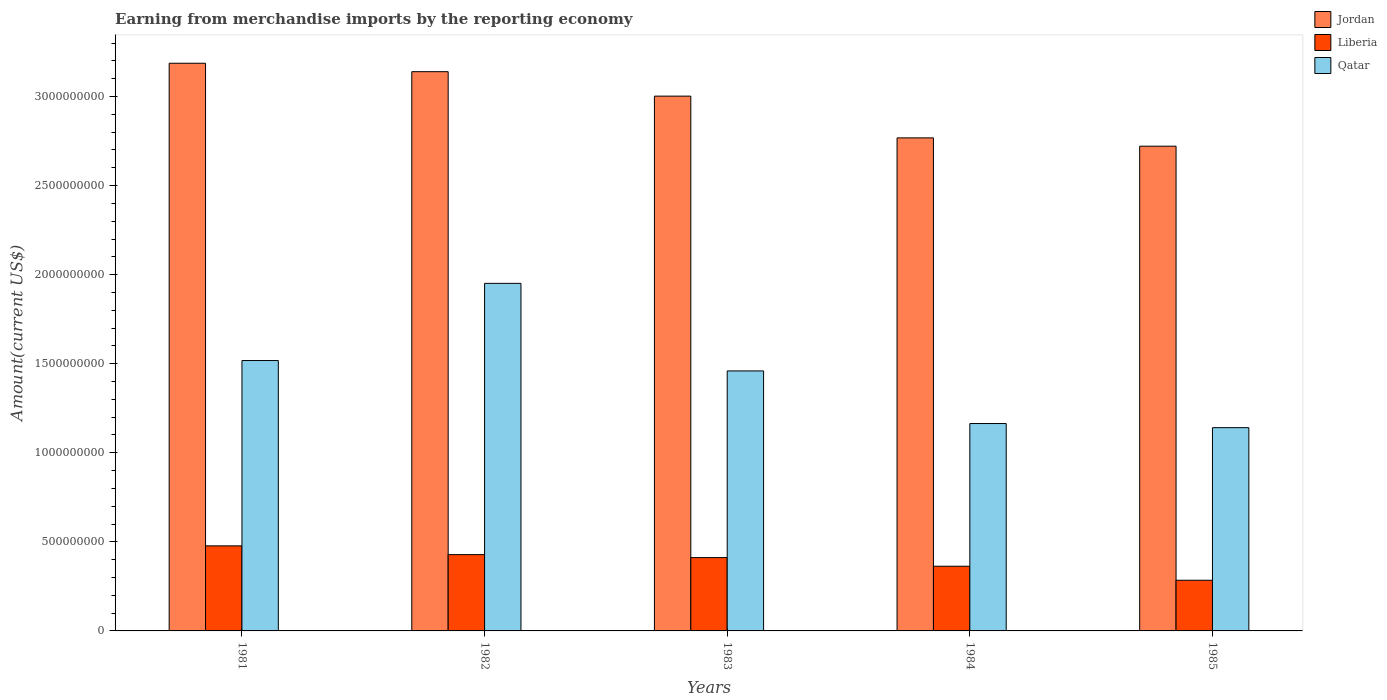How many groups of bars are there?
Provide a short and direct response. 5. How many bars are there on the 1st tick from the right?
Provide a short and direct response. 3. What is the label of the 5th group of bars from the left?
Provide a short and direct response. 1985. In how many cases, is the number of bars for a given year not equal to the number of legend labels?
Your response must be concise. 0. What is the amount earned from merchandise imports in Liberia in 1985?
Keep it short and to the point. 2.84e+08. Across all years, what is the maximum amount earned from merchandise imports in Liberia?
Ensure brevity in your answer.  4.77e+08. Across all years, what is the minimum amount earned from merchandise imports in Jordan?
Ensure brevity in your answer.  2.72e+09. In which year was the amount earned from merchandise imports in Jordan maximum?
Your answer should be very brief. 1981. What is the total amount earned from merchandise imports in Qatar in the graph?
Offer a very short reply. 7.23e+09. What is the difference between the amount earned from merchandise imports in Liberia in 1981 and that in 1982?
Give a very brief answer. 4.91e+07. What is the difference between the amount earned from merchandise imports in Jordan in 1981 and the amount earned from merchandise imports in Qatar in 1982?
Ensure brevity in your answer.  1.24e+09. What is the average amount earned from merchandise imports in Liberia per year?
Your response must be concise. 3.93e+08. In the year 1983, what is the difference between the amount earned from merchandise imports in Jordan and amount earned from merchandise imports in Qatar?
Offer a very short reply. 1.54e+09. What is the ratio of the amount earned from merchandise imports in Qatar in 1983 to that in 1984?
Make the answer very short. 1.25. Is the amount earned from merchandise imports in Qatar in 1982 less than that in 1983?
Keep it short and to the point. No. What is the difference between the highest and the second highest amount earned from merchandise imports in Jordan?
Your answer should be compact. 4.73e+07. What is the difference between the highest and the lowest amount earned from merchandise imports in Liberia?
Your answer should be very brief. 1.93e+08. What does the 2nd bar from the left in 1982 represents?
Offer a terse response. Liberia. What does the 2nd bar from the right in 1982 represents?
Your response must be concise. Liberia. Does the graph contain any zero values?
Make the answer very short. No. What is the title of the graph?
Offer a very short reply. Earning from merchandise imports by the reporting economy. Does "Tuvalu" appear as one of the legend labels in the graph?
Your answer should be very brief. No. What is the label or title of the Y-axis?
Offer a terse response. Amount(current US$). What is the Amount(current US$) in Jordan in 1981?
Ensure brevity in your answer.  3.19e+09. What is the Amount(current US$) in Liberia in 1981?
Ensure brevity in your answer.  4.77e+08. What is the Amount(current US$) in Qatar in 1981?
Your answer should be very brief. 1.52e+09. What is the Amount(current US$) of Jordan in 1982?
Give a very brief answer. 3.14e+09. What is the Amount(current US$) of Liberia in 1982?
Make the answer very short. 4.28e+08. What is the Amount(current US$) of Qatar in 1982?
Your answer should be very brief. 1.95e+09. What is the Amount(current US$) of Jordan in 1983?
Offer a very short reply. 3.00e+09. What is the Amount(current US$) of Liberia in 1983?
Offer a very short reply. 4.12e+08. What is the Amount(current US$) of Qatar in 1983?
Your answer should be compact. 1.46e+09. What is the Amount(current US$) of Jordan in 1984?
Give a very brief answer. 2.77e+09. What is the Amount(current US$) in Liberia in 1984?
Offer a terse response. 3.63e+08. What is the Amount(current US$) of Qatar in 1984?
Make the answer very short. 1.16e+09. What is the Amount(current US$) in Jordan in 1985?
Provide a short and direct response. 2.72e+09. What is the Amount(current US$) of Liberia in 1985?
Ensure brevity in your answer.  2.84e+08. What is the Amount(current US$) of Qatar in 1985?
Give a very brief answer. 1.14e+09. Across all years, what is the maximum Amount(current US$) in Jordan?
Your answer should be very brief. 3.19e+09. Across all years, what is the maximum Amount(current US$) in Liberia?
Your answer should be compact. 4.77e+08. Across all years, what is the maximum Amount(current US$) in Qatar?
Keep it short and to the point. 1.95e+09. Across all years, what is the minimum Amount(current US$) in Jordan?
Offer a very short reply. 2.72e+09. Across all years, what is the minimum Amount(current US$) in Liberia?
Offer a terse response. 2.84e+08. Across all years, what is the minimum Amount(current US$) in Qatar?
Offer a terse response. 1.14e+09. What is the total Amount(current US$) of Jordan in the graph?
Make the answer very short. 1.48e+1. What is the total Amount(current US$) in Liberia in the graph?
Your answer should be very brief. 1.96e+09. What is the total Amount(current US$) of Qatar in the graph?
Make the answer very short. 7.23e+09. What is the difference between the Amount(current US$) of Jordan in 1981 and that in 1982?
Give a very brief answer. 4.73e+07. What is the difference between the Amount(current US$) of Liberia in 1981 and that in 1982?
Give a very brief answer. 4.91e+07. What is the difference between the Amount(current US$) of Qatar in 1981 and that in 1982?
Keep it short and to the point. -4.33e+08. What is the difference between the Amount(current US$) of Jordan in 1981 and that in 1983?
Offer a very short reply. 1.85e+08. What is the difference between the Amount(current US$) in Liberia in 1981 and that in 1983?
Offer a terse response. 6.58e+07. What is the difference between the Amount(current US$) in Qatar in 1981 and that in 1983?
Offer a terse response. 5.83e+07. What is the difference between the Amount(current US$) of Jordan in 1981 and that in 1984?
Provide a short and direct response. 4.19e+08. What is the difference between the Amount(current US$) in Liberia in 1981 and that in 1984?
Your response must be concise. 1.14e+08. What is the difference between the Amount(current US$) of Qatar in 1981 and that in 1984?
Offer a terse response. 3.54e+08. What is the difference between the Amount(current US$) in Jordan in 1981 and that in 1985?
Offer a terse response. 4.66e+08. What is the difference between the Amount(current US$) of Liberia in 1981 and that in 1985?
Your response must be concise. 1.93e+08. What is the difference between the Amount(current US$) of Qatar in 1981 and that in 1985?
Make the answer very short. 3.77e+08. What is the difference between the Amount(current US$) of Jordan in 1982 and that in 1983?
Your answer should be compact. 1.37e+08. What is the difference between the Amount(current US$) of Liberia in 1982 and that in 1983?
Keep it short and to the point. 1.67e+07. What is the difference between the Amount(current US$) in Qatar in 1982 and that in 1983?
Provide a short and direct response. 4.92e+08. What is the difference between the Amount(current US$) of Jordan in 1982 and that in 1984?
Keep it short and to the point. 3.72e+08. What is the difference between the Amount(current US$) in Liberia in 1982 and that in 1984?
Keep it short and to the point. 6.51e+07. What is the difference between the Amount(current US$) in Qatar in 1982 and that in 1984?
Give a very brief answer. 7.87e+08. What is the difference between the Amount(current US$) in Jordan in 1982 and that in 1985?
Give a very brief answer. 4.18e+08. What is the difference between the Amount(current US$) of Liberia in 1982 and that in 1985?
Provide a succinct answer. 1.44e+08. What is the difference between the Amount(current US$) in Qatar in 1982 and that in 1985?
Your response must be concise. 8.10e+08. What is the difference between the Amount(current US$) in Jordan in 1983 and that in 1984?
Keep it short and to the point. 2.34e+08. What is the difference between the Amount(current US$) of Liberia in 1983 and that in 1984?
Provide a succinct answer. 4.84e+07. What is the difference between the Amount(current US$) of Qatar in 1983 and that in 1984?
Make the answer very short. 2.95e+08. What is the difference between the Amount(current US$) of Jordan in 1983 and that in 1985?
Offer a very short reply. 2.81e+08. What is the difference between the Amount(current US$) of Liberia in 1983 and that in 1985?
Your response must be concise. 1.27e+08. What is the difference between the Amount(current US$) in Qatar in 1983 and that in 1985?
Offer a terse response. 3.18e+08. What is the difference between the Amount(current US$) in Jordan in 1984 and that in 1985?
Your answer should be compact. 4.66e+07. What is the difference between the Amount(current US$) of Liberia in 1984 and that in 1985?
Ensure brevity in your answer.  7.88e+07. What is the difference between the Amount(current US$) in Qatar in 1984 and that in 1985?
Your answer should be very brief. 2.31e+07. What is the difference between the Amount(current US$) of Jordan in 1981 and the Amount(current US$) of Liberia in 1982?
Offer a very short reply. 2.76e+09. What is the difference between the Amount(current US$) of Jordan in 1981 and the Amount(current US$) of Qatar in 1982?
Ensure brevity in your answer.  1.24e+09. What is the difference between the Amount(current US$) in Liberia in 1981 and the Amount(current US$) in Qatar in 1982?
Make the answer very short. -1.47e+09. What is the difference between the Amount(current US$) in Jordan in 1981 and the Amount(current US$) in Liberia in 1983?
Provide a succinct answer. 2.77e+09. What is the difference between the Amount(current US$) of Jordan in 1981 and the Amount(current US$) of Qatar in 1983?
Your response must be concise. 1.73e+09. What is the difference between the Amount(current US$) in Liberia in 1981 and the Amount(current US$) in Qatar in 1983?
Offer a terse response. -9.82e+08. What is the difference between the Amount(current US$) of Jordan in 1981 and the Amount(current US$) of Liberia in 1984?
Provide a succinct answer. 2.82e+09. What is the difference between the Amount(current US$) in Jordan in 1981 and the Amount(current US$) in Qatar in 1984?
Provide a short and direct response. 2.02e+09. What is the difference between the Amount(current US$) of Liberia in 1981 and the Amount(current US$) of Qatar in 1984?
Ensure brevity in your answer.  -6.87e+08. What is the difference between the Amount(current US$) in Jordan in 1981 and the Amount(current US$) in Liberia in 1985?
Offer a terse response. 2.90e+09. What is the difference between the Amount(current US$) in Jordan in 1981 and the Amount(current US$) in Qatar in 1985?
Provide a succinct answer. 2.05e+09. What is the difference between the Amount(current US$) in Liberia in 1981 and the Amount(current US$) in Qatar in 1985?
Your answer should be compact. -6.64e+08. What is the difference between the Amount(current US$) of Jordan in 1982 and the Amount(current US$) of Liberia in 1983?
Make the answer very short. 2.73e+09. What is the difference between the Amount(current US$) in Jordan in 1982 and the Amount(current US$) in Qatar in 1983?
Offer a terse response. 1.68e+09. What is the difference between the Amount(current US$) in Liberia in 1982 and the Amount(current US$) in Qatar in 1983?
Offer a terse response. -1.03e+09. What is the difference between the Amount(current US$) in Jordan in 1982 and the Amount(current US$) in Liberia in 1984?
Provide a succinct answer. 2.78e+09. What is the difference between the Amount(current US$) in Jordan in 1982 and the Amount(current US$) in Qatar in 1984?
Provide a succinct answer. 1.98e+09. What is the difference between the Amount(current US$) in Liberia in 1982 and the Amount(current US$) in Qatar in 1984?
Offer a terse response. -7.36e+08. What is the difference between the Amount(current US$) of Jordan in 1982 and the Amount(current US$) of Liberia in 1985?
Your answer should be compact. 2.85e+09. What is the difference between the Amount(current US$) of Jordan in 1982 and the Amount(current US$) of Qatar in 1985?
Make the answer very short. 2.00e+09. What is the difference between the Amount(current US$) in Liberia in 1982 and the Amount(current US$) in Qatar in 1985?
Ensure brevity in your answer.  -7.13e+08. What is the difference between the Amount(current US$) of Jordan in 1983 and the Amount(current US$) of Liberia in 1984?
Provide a succinct answer. 2.64e+09. What is the difference between the Amount(current US$) in Jordan in 1983 and the Amount(current US$) in Qatar in 1984?
Your answer should be very brief. 1.84e+09. What is the difference between the Amount(current US$) in Liberia in 1983 and the Amount(current US$) in Qatar in 1984?
Your response must be concise. -7.53e+08. What is the difference between the Amount(current US$) of Jordan in 1983 and the Amount(current US$) of Liberia in 1985?
Offer a very short reply. 2.72e+09. What is the difference between the Amount(current US$) in Jordan in 1983 and the Amount(current US$) in Qatar in 1985?
Your answer should be compact. 1.86e+09. What is the difference between the Amount(current US$) in Liberia in 1983 and the Amount(current US$) in Qatar in 1985?
Give a very brief answer. -7.29e+08. What is the difference between the Amount(current US$) of Jordan in 1984 and the Amount(current US$) of Liberia in 1985?
Your answer should be very brief. 2.48e+09. What is the difference between the Amount(current US$) in Jordan in 1984 and the Amount(current US$) in Qatar in 1985?
Ensure brevity in your answer.  1.63e+09. What is the difference between the Amount(current US$) of Liberia in 1984 and the Amount(current US$) of Qatar in 1985?
Offer a terse response. -7.78e+08. What is the average Amount(current US$) of Jordan per year?
Offer a very short reply. 2.96e+09. What is the average Amount(current US$) of Liberia per year?
Offer a very short reply. 3.93e+08. What is the average Amount(current US$) of Qatar per year?
Offer a very short reply. 1.45e+09. In the year 1981, what is the difference between the Amount(current US$) of Jordan and Amount(current US$) of Liberia?
Offer a very short reply. 2.71e+09. In the year 1981, what is the difference between the Amount(current US$) in Jordan and Amount(current US$) in Qatar?
Give a very brief answer. 1.67e+09. In the year 1981, what is the difference between the Amount(current US$) of Liberia and Amount(current US$) of Qatar?
Ensure brevity in your answer.  -1.04e+09. In the year 1982, what is the difference between the Amount(current US$) of Jordan and Amount(current US$) of Liberia?
Keep it short and to the point. 2.71e+09. In the year 1982, what is the difference between the Amount(current US$) of Jordan and Amount(current US$) of Qatar?
Your answer should be compact. 1.19e+09. In the year 1982, what is the difference between the Amount(current US$) of Liberia and Amount(current US$) of Qatar?
Your answer should be compact. -1.52e+09. In the year 1983, what is the difference between the Amount(current US$) in Jordan and Amount(current US$) in Liberia?
Ensure brevity in your answer.  2.59e+09. In the year 1983, what is the difference between the Amount(current US$) of Jordan and Amount(current US$) of Qatar?
Provide a succinct answer. 1.54e+09. In the year 1983, what is the difference between the Amount(current US$) in Liberia and Amount(current US$) in Qatar?
Provide a short and direct response. -1.05e+09. In the year 1984, what is the difference between the Amount(current US$) of Jordan and Amount(current US$) of Liberia?
Your answer should be compact. 2.40e+09. In the year 1984, what is the difference between the Amount(current US$) in Jordan and Amount(current US$) in Qatar?
Offer a terse response. 1.60e+09. In the year 1984, what is the difference between the Amount(current US$) in Liberia and Amount(current US$) in Qatar?
Give a very brief answer. -8.01e+08. In the year 1985, what is the difference between the Amount(current US$) of Jordan and Amount(current US$) of Liberia?
Your answer should be very brief. 2.44e+09. In the year 1985, what is the difference between the Amount(current US$) in Jordan and Amount(current US$) in Qatar?
Your answer should be compact. 1.58e+09. In the year 1985, what is the difference between the Amount(current US$) in Liberia and Amount(current US$) in Qatar?
Offer a terse response. -8.57e+08. What is the ratio of the Amount(current US$) in Jordan in 1981 to that in 1982?
Your response must be concise. 1.02. What is the ratio of the Amount(current US$) of Liberia in 1981 to that in 1982?
Offer a terse response. 1.11. What is the ratio of the Amount(current US$) of Qatar in 1981 to that in 1982?
Provide a succinct answer. 0.78. What is the ratio of the Amount(current US$) in Jordan in 1981 to that in 1983?
Provide a short and direct response. 1.06. What is the ratio of the Amount(current US$) of Liberia in 1981 to that in 1983?
Make the answer very short. 1.16. What is the ratio of the Amount(current US$) of Jordan in 1981 to that in 1984?
Your response must be concise. 1.15. What is the ratio of the Amount(current US$) of Liberia in 1981 to that in 1984?
Keep it short and to the point. 1.31. What is the ratio of the Amount(current US$) of Qatar in 1981 to that in 1984?
Your response must be concise. 1.3. What is the ratio of the Amount(current US$) of Jordan in 1981 to that in 1985?
Make the answer very short. 1.17. What is the ratio of the Amount(current US$) of Liberia in 1981 to that in 1985?
Make the answer very short. 1.68. What is the ratio of the Amount(current US$) in Qatar in 1981 to that in 1985?
Provide a short and direct response. 1.33. What is the ratio of the Amount(current US$) of Jordan in 1982 to that in 1983?
Offer a terse response. 1.05. What is the ratio of the Amount(current US$) of Liberia in 1982 to that in 1983?
Ensure brevity in your answer.  1.04. What is the ratio of the Amount(current US$) of Qatar in 1982 to that in 1983?
Ensure brevity in your answer.  1.34. What is the ratio of the Amount(current US$) in Jordan in 1982 to that in 1984?
Keep it short and to the point. 1.13. What is the ratio of the Amount(current US$) of Liberia in 1982 to that in 1984?
Provide a short and direct response. 1.18. What is the ratio of the Amount(current US$) in Qatar in 1982 to that in 1984?
Your response must be concise. 1.68. What is the ratio of the Amount(current US$) in Jordan in 1982 to that in 1985?
Offer a terse response. 1.15. What is the ratio of the Amount(current US$) of Liberia in 1982 to that in 1985?
Your answer should be compact. 1.51. What is the ratio of the Amount(current US$) of Qatar in 1982 to that in 1985?
Keep it short and to the point. 1.71. What is the ratio of the Amount(current US$) in Jordan in 1983 to that in 1984?
Keep it short and to the point. 1.08. What is the ratio of the Amount(current US$) in Liberia in 1983 to that in 1984?
Make the answer very short. 1.13. What is the ratio of the Amount(current US$) of Qatar in 1983 to that in 1984?
Ensure brevity in your answer.  1.25. What is the ratio of the Amount(current US$) of Jordan in 1983 to that in 1985?
Offer a very short reply. 1.1. What is the ratio of the Amount(current US$) of Liberia in 1983 to that in 1985?
Offer a terse response. 1.45. What is the ratio of the Amount(current US$) in Qatar in 1983 to that in 1985?
Your answer should be compact. 1.28. What is the ratio of the Amount(current US$) in Jordan in 1984 to that in 1985?
Offer a very short reply. 1.02. What is the ratio of the Amount(current US$) in Liberia in 1984 to that in 1985?
Your response must be concise. 1.28. What is the ratio of the Amount(current US$) in Qatar in 1984 to that in 1985?
Your answer should be compact. 1.02. What is the difference between the highest and the second highest Amount(current US$) of Jordan?
Give a very brief answer. 4.73e+07. What is the difference between the highest and the second highest Amount(current US$) in Liberia?
Offer a very short reply. 4.91e+07. What is the difference between the highest and the second highest Amount(current US$) of Qatar?
Offer a terse response. 4.33e+08. What is the difference between the highest and the lowest Amount(current US$) of Jordan?
Provide a succinct answer. 4.66e+08. What is the difference between the highest and the lowest Amount(current US$) of Liberia?
Keep it short and to the point. 1.93e+08. What is the difference between the highest and the lowest Amount(current US$) in Qatar?
Provide a succinct answer. 8.10e+08. 